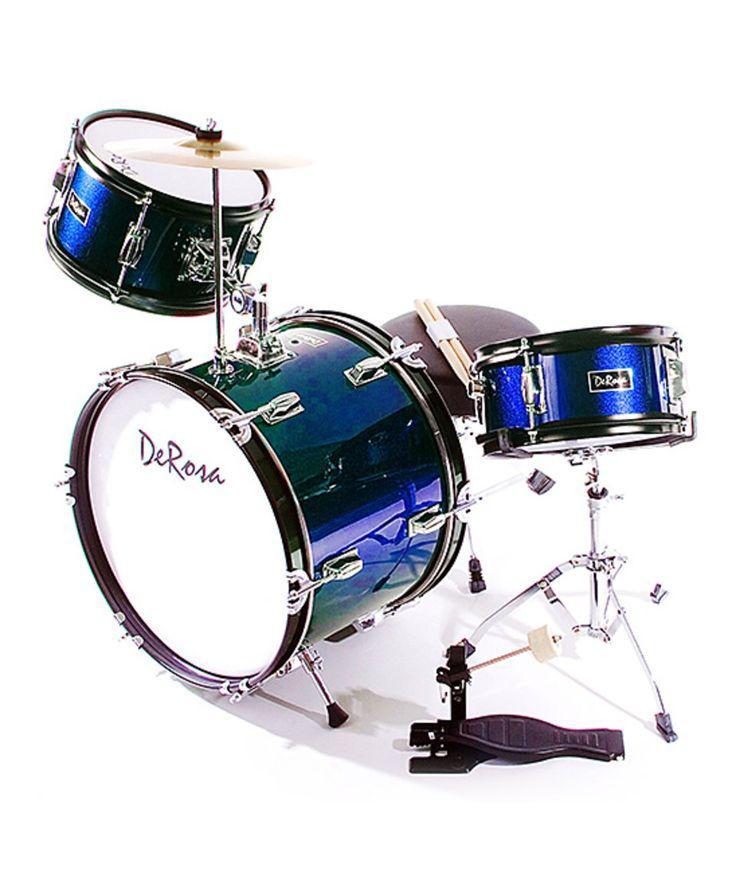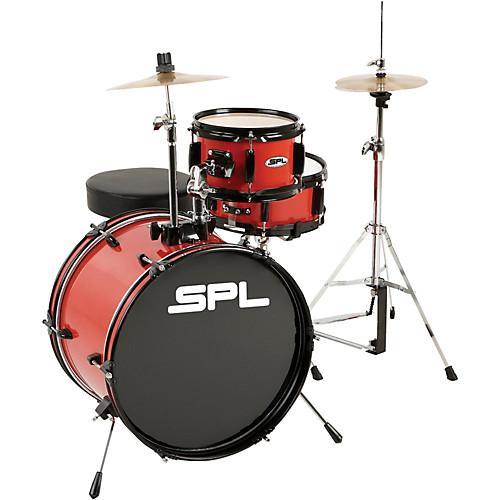The first image is the image on the left, the second image is the image on the right. For the images displayed, is the sentence "Eight or more drums are visible." factually correct? Answer yes or no. No. 